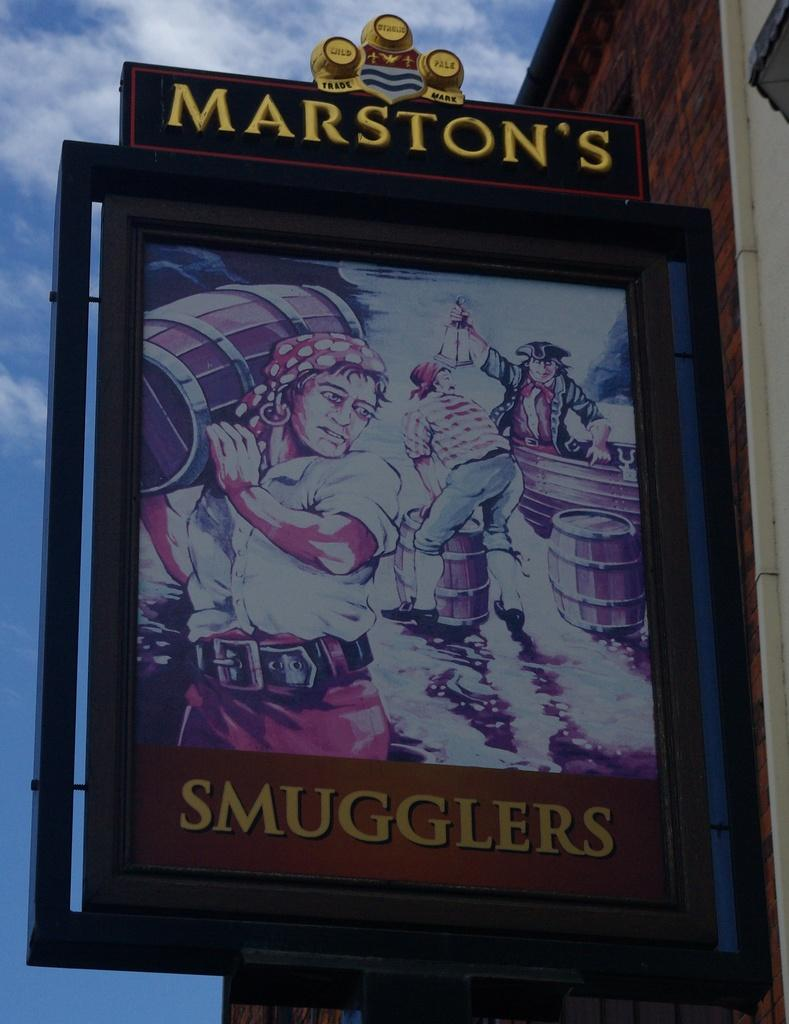<image>
Provide a brief description of the given image. A sign that says "Marston's Smugglers" has pirates on it. 